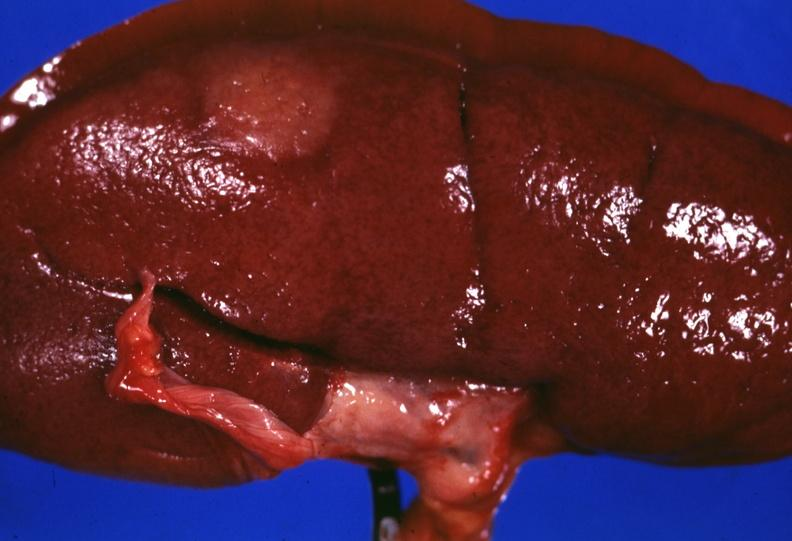s no tissue recognizable as ovary present?
Answer the question using a single word or phrase. No 